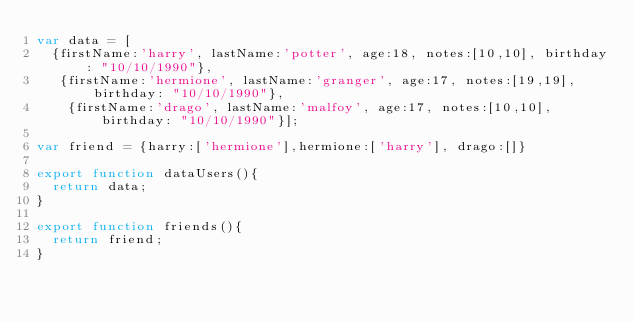<code> <loc_0><loc_0><loc_500><loc_500><_TypeScript_>var data = [
  {firstName:'harry', lastName:'potter', age:18, notes:[10,10], birthday: "10/10/1990"},
   {firstName:'hermione', lastName:'granger', age:17, notes:[19,19], birthday: "10/10/1990"},
    {firstName:'drago', lastName:'malfoy', age:17, notes:[10,10], birthday: "10/10/1990"}];

var friend = {harry:['hermione'],hermione:['harry'], drago:[]}

export function dataUsers(){
  return data;
}

export function friends(){
  return friend;
}
</code> 